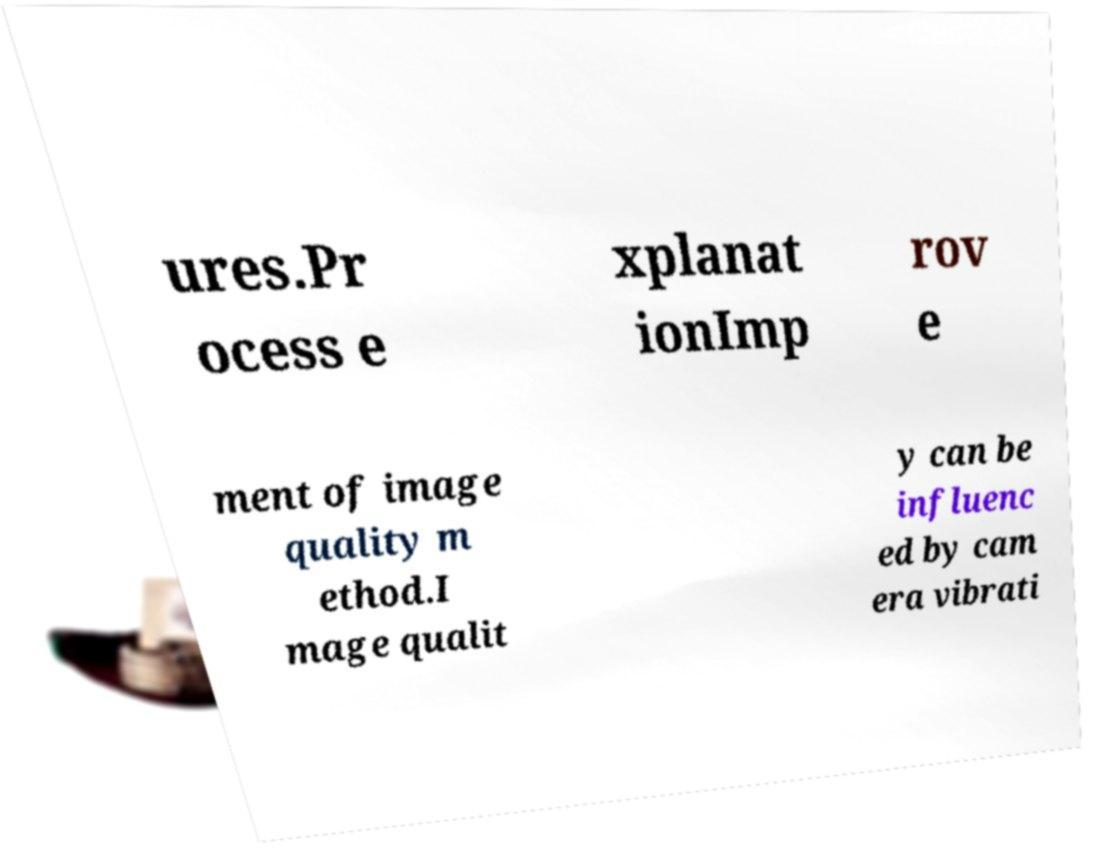I need the written content from this picture converted into text. Can you do that? ures.Pr ocess e xplanat ionImp rov e ment of image quality m ethod.I mage qualit y can be influenc ed by cam era vibrati 